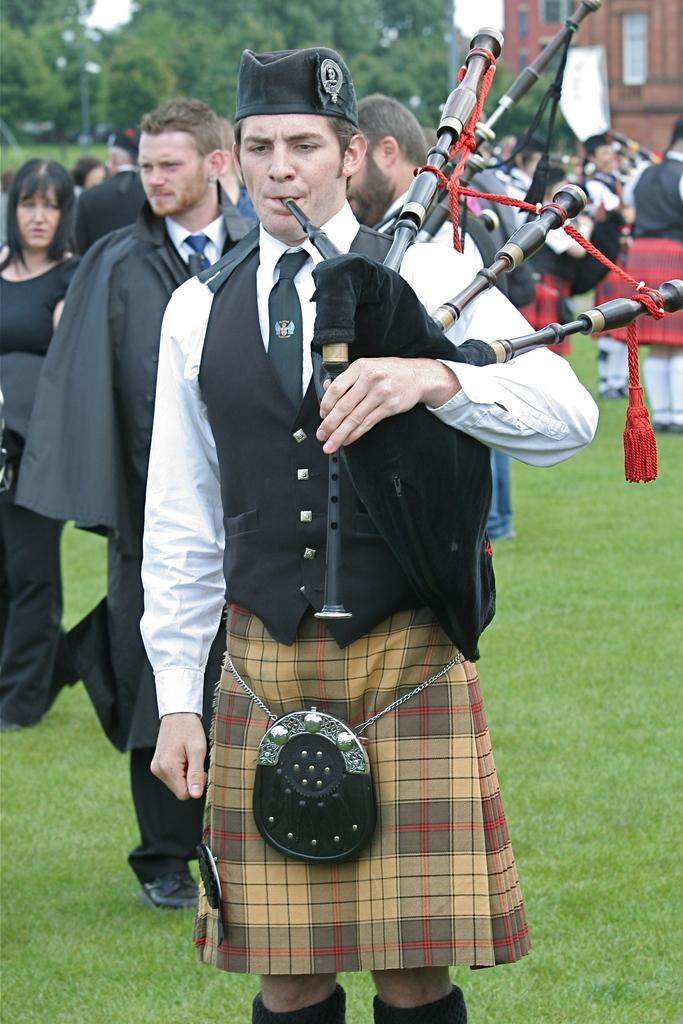How would you summarize this image in a sentence or two? This image is taken outdoors. At the bottom of the image there is a ground with grass on it. In the middle of the image a man is standing on the ground and playing music with a musical instrument. In the background there are a few trees and a building and many people are standing on the ground. 